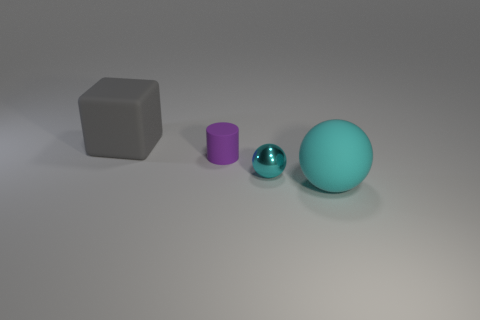Add 3 gray rubber things. How many objects exist? 7 Subtract all cylinders. How many objects are left? 3 Add 3 blue metal blocks. How many blue metal blocks exist? 3 Subtract 0 blue spheres. How many objects are left? 4 Subtract all small cyan shiny objects. Subtract all tiny matte cylinders. How many objects are left? 2 Add 1 large objects. How many large objects are left? 3 